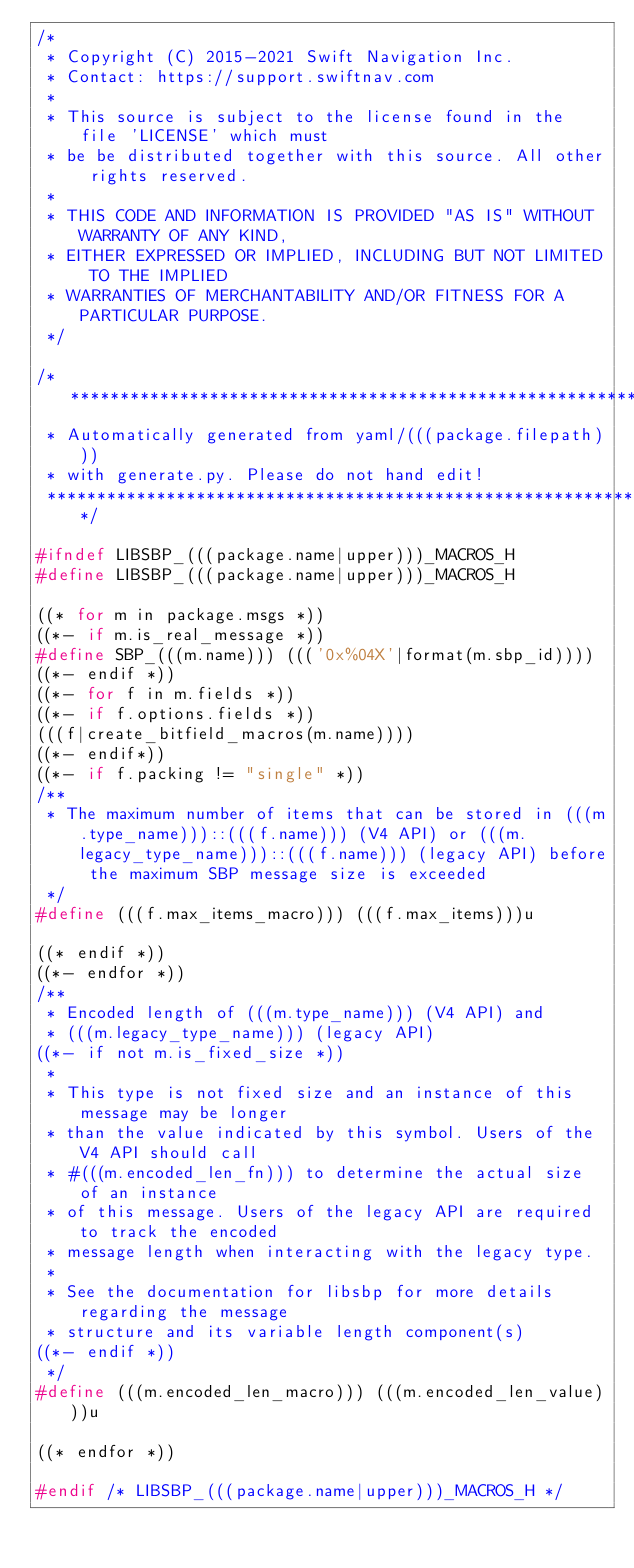Convert code to text. <code><loc_0><loc_0><loc_500><loc_500><_C_>/*
 * Copyright (C) 2015-2021 Swift Navigation Inc.
 * Contact: https://support.swiftnav.com
 *
 * This source is subject to the license found in the file 'LICENSE' which must
 * be be distributed together with this source. All other rights reserved.
 *
 * THIS CODE AND INFORMATION IS PROVIDED "AS IS" WITHOUT WARRANTY OF ANY KIND,
 * EITHER EXPRESSED OR IMPLIED, INCLUDING BUT NOT LIMITED TO THE IMPLIED
 * WARRANTIES OF MERCHANTABILITY AND/OR FITNESS FOR A PARTICULAR PURPOSE.
 */

/*****************************************************************************
 * Automatically generated from yaml/(((package.filepath)))
 * with generate.py. Please do not hand edit!
 *****************************************************************************/

#ifndef LIBSBP_(((package.name|upper)))_MACROS_H
#define LIBSBP_(((package.name|upper)))_MACROS_H

((* for m in package.msgs *))
((*- if m.is_real_message *))
#define SBP_(((m.name))) ((('0x%04X'|format(m.sbp_id))))
((*- endif *))
((*- for f in m.fields *))
((*- if f.options.fields *))
(((f|create_bitfield_macros(m.name))))
((*- endif*))
((*- if f.packing != "single" *))
/**
 * The maximum number of items that can be stored in (((m.type_name)))::(((f.name))) (V4 API) or (((m.legacy_type_name)))::(((f.name))) (legacy API) before the maximum SBP message size is exceeded
 */
#define (((f.max_items_macro))) (((f.max_items)))u

((* endif *))
((*- endfor *))
/**
 * Encoded length of (((m.type_name))) (V4 API) and 
 * (((m.legacy_type_name))) (legacy API)
((*- if not m.is_fixed_size *))
 *
 * This type is not fixed size and an instance of this message may be longer 
 * than the value indicated by this symbol. Users of the V4 API should call 
 * #(((m.encoded_len_fn))) to determine the actual size of an instance 
 * of this message. Users of the legacy API are required to track the encoded 
 * message length when interacting with the legacy type.
 *
 * See the documentation for libsbp for more details regarding the message 
 * structure and its variable length component(s)
((*- endif *))
 */
#define (((m.encoded_len_macro))) (((m.encoded_len_value)))u

((* endfor *))

#endif /* LIBSBP_(((package.name|upper)))_MACROS_H */

</code> 